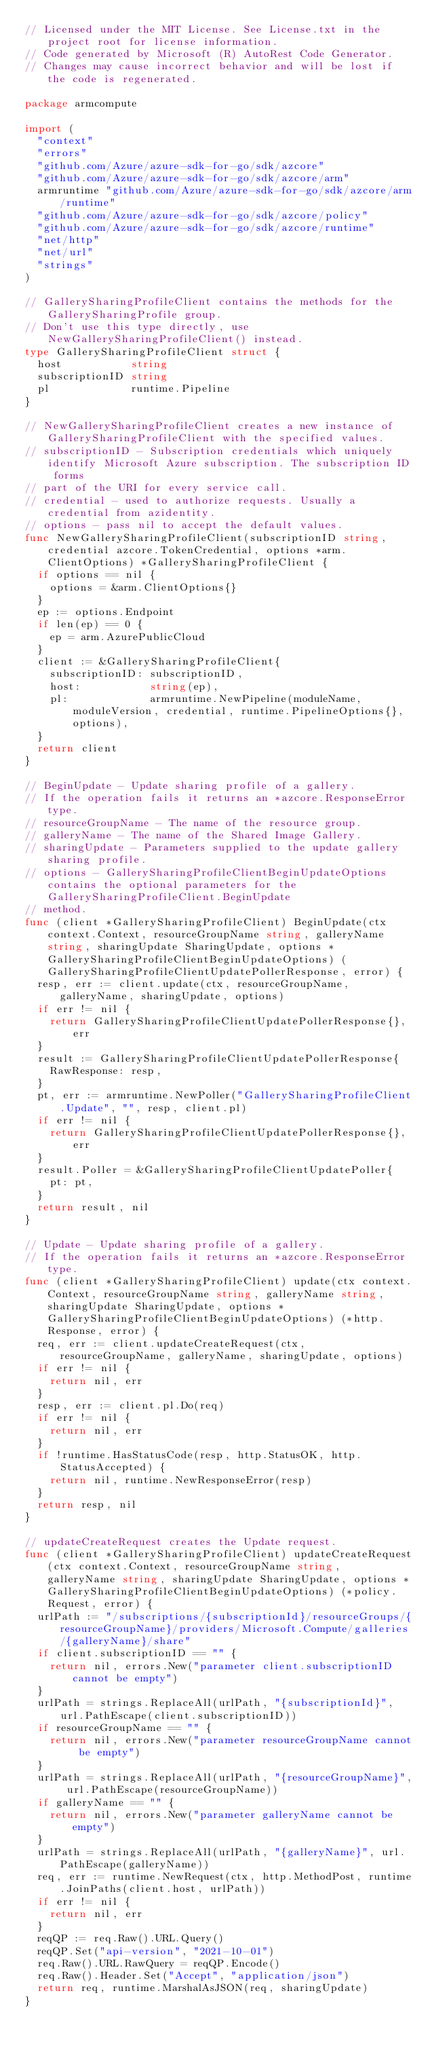<code> <loc_0><loc_0><loc_500><loc_500><_Go_>// Licensed under the MIT License. See License.txt in the project root for license information.
// Code generated by Microsoft (R) AutoRest Code Generator.
// Changes may cause incorrect behavior and will be lost if the code is regenerated.

package armcompute

import (
	"context"
	"errors"
	"github.com/Azure/azure-sdk-for-go/sdk/azcore"
	"github.com/Azure/azure-sdk-for-go/sdk/azcore/arm"
	armruntime "github.com/Azure/azure-sdk-for-go/sdk/azcore/arm/runtime"
	"github.com/Azure/azure-sdk-for-go/sdk/azcore/policy"
	"github.com/Azure/azure-sdk-for-go/sdk/azcore/runtime"
	"net/http"
	"net/url"
	"strings"
)

// GallerySharingProfileClient contains the methods for the GallerySharingProfile group.
// Don't use this type directly, use NewGallerySharingProfileClient() instead.
type GallerySharingProfileClient struct {
	host           string
	subscriptionID string
	pl             runtime.Pipeline
}

// NewGallerySharingProfileClient creates a new instance of GallerySharingProfileClient with the specified values.
// subscriptionID - Subscription credentials which uniquely identify Microsoft Azure subscription. The subscription ID forms
// part of the URI for every service call.
// credential - used to authorize requests. Usually a credential from azidentity.
// options - pass nil to accept the default values.
func NewGallerySharingProfileClient(subscriptionID string, credential azcore.TokenCredential, options *arm.ClientOptions) *GallerySharingProfileClient {
	if options == nil {
		options = &arm.ClientOptions{}
	}
	ep := options.Endpoint
	if len(ep) == 0 {
		ep = arm.AzurePublicCloud
	}
	client := &GallerySharingProfileClient{
		subscriptionID: subscriptionID,
		host:           string(ep),
		pl:             armruntime.NewPipeline(moduleName, moduleVersion, credential, runtime.PipelineOptions{}, options),
	}
	return client
}

// BeginUpdate - Update sharing profile of a gallery.
// If the operation fails it returns an *azcore.ResponseError type.
// resourceGroupName - The name of the resource group.
// galleryName - The name of the Shared Image Gallery.
// sharingUpdate - Parameters supplied to the update gallery sharing profile.
// options - GallerySharingProfileClientBeginUpdateOptions contains the optional parameters for the GallerySharingProfileClient.BeginUpdate
// method.
func (client *GallerySharingProfileClient) BeginUpdate(ctx context.Context, resourceGroupName string, galleryName string, sharingUpdate SharingUpdate, options *GallerySharingProfileClientBeginUpdateOptions) (GallerySharingProfileClientUpdatePollerResponse, error) {
	resp, err := client.update(ctx, resourceGroupName, galleryName, sharingUpdate, options)
	if err != nil {
		return GallerySharingProfileClientUpdatePollerResponse{}, err
	}
	result := GallerySharingProfileClientUpdatePollerResponse{
		RawResponse: resp,
	}
	pt, err := armruntime.NewPoller("GallerySharingProfileClient.Update", "", resp, client.pl)
	if err != nil {
		return GallerySharingProfileClientUpdatePollerResponse{}, err
	}
	result.Poller = &GallerySharingProfileClientUpdatePoller{
		pt: pt,
	}
	return result, nil
}

// Update - Update sharing profile of a gallery.
// If the operation fails it returns an *azcore.ResponseError type.
func (client *GallerySharingProfileClient) update(ctx context.Context, resourceGroupName string, galleryName string, sharingUpdate SharingUpdate, options *GallerySharingProfileClientBeginUpdateOptions) (*http.Response, error) {
	req, err := client.updateCreateRequest(ctx, resourceGroupName, galleryName, sharingUpdate, options)
	if err != nil {
		return nil, err
	}
	resp, err := client.pl.Do(req)
	if err != nil {
		return nil, err
	}
	if !runtime.HasStatusCode(resp, http.StatusOK, http.StatusAccepted) {
		return nil, runtime.NewResponseError(resp)
	}
	return resp, nil
}

// updateCreateRequest creates the Update request.
func (client *GallerySharingProfileClient) updateCreateRequest(ctx context.Context, resourceGroupName string, galleryName string, sharingUpdate SharingUpdate, options *GallerySharingProfileClientBeginUpdateOptions) (*policy.Request, error) {
	urlPath := "/subscriptions/{subscriptionId}/resourceGroups/{resourceGroupName}/providers/Microsoft.Compute/galleries/{galleryName}/share"
	if client.subscriptionID == "" {
		return nil, errors.New("parameter client.subscriptionID cannot be empty")
	}
	urlPath = strings.ReplaceAll(urlPath, "{subscriptionId}", url.PathEscape(client.subscriptionID))
	if resourceGroupName == "" {
		return nil, errors.New("parameter resourceGroupName cannot be empty")
	}
	urlPath = strings.ReplaceAll(urlPath, "{resourceGroupName}", url.PathEscape(resourceGroupName))
	if galleryName == "" {
		return nil, errors.New("parameter galleryName cannot be empty")
	}
	urlPath = strings.ReplaceAll(urlPath, "{galleryName}", url.PathEscape(galleryName))
	req, err := runtime.NewRequest(ctx, http.MethodPost, runtime.JoinPaths(client.host, urlPath))
	if err != nil {
		return nil, err
	}
	reqQP := req.Raw().URL.Query()
	reqQP.Set("api-version", "2021-10-01")
	req.Raw().URL.RawQuery = reqQP.Encode()
	req.Raw().Header.Set("Accept", "application/json")
	return req, runtime.MarshalAsJSON(req, sharingUpdate)
}
</code> 